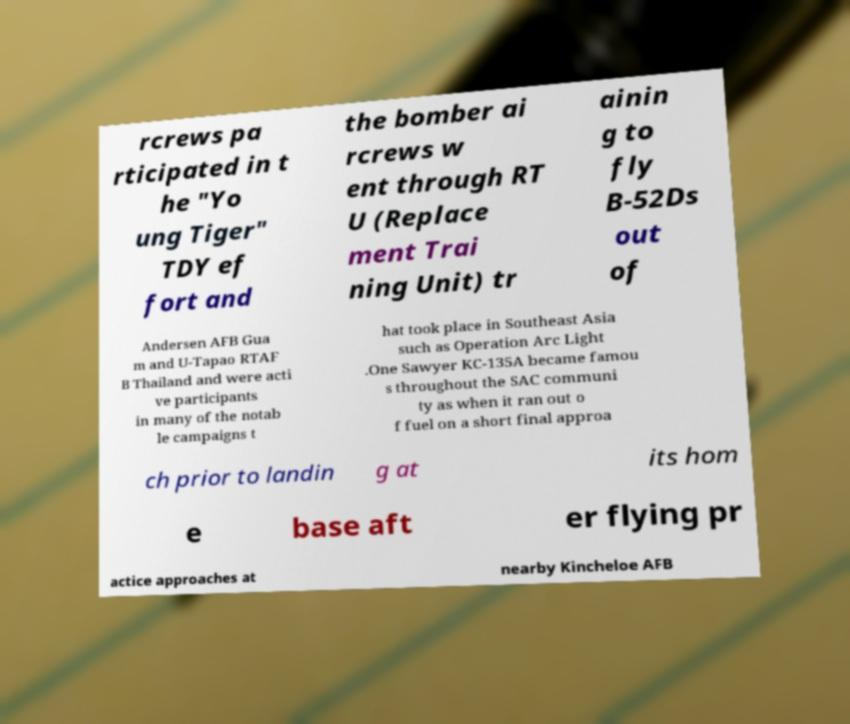Could you assist in decoding the text presented in this image and type it out clearly? rcrews pa rticipated in t he "Yo ung Tiger" TDY ef fort and the bomber ai rcrews w ent through RT U (Replace ment Trai ning Unit) tr ainin g to fly B-52Ds out of Andersen AFB Gua m and U-Tapao RTAF B Thailand and were acti ve participants in many of the notab le campaigns t hat took place in Southeast Asia such as Operation Arc Light .One Sawyer KC-135A became famou s throughout the SAC communi ty as when it ran out o f fuel on a short final approa ch prior to landin g at its hom e base aft er flying pr actice approaches at nearby Kincheloe AFB 